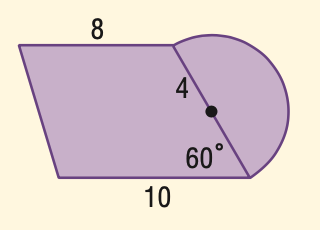Question: Find the area of the figure to the nearest tenth.
Choices:
A. 80.6
B. 87.5
C. 94.4
D. 112.6
Answer with the letter. Answer: B 